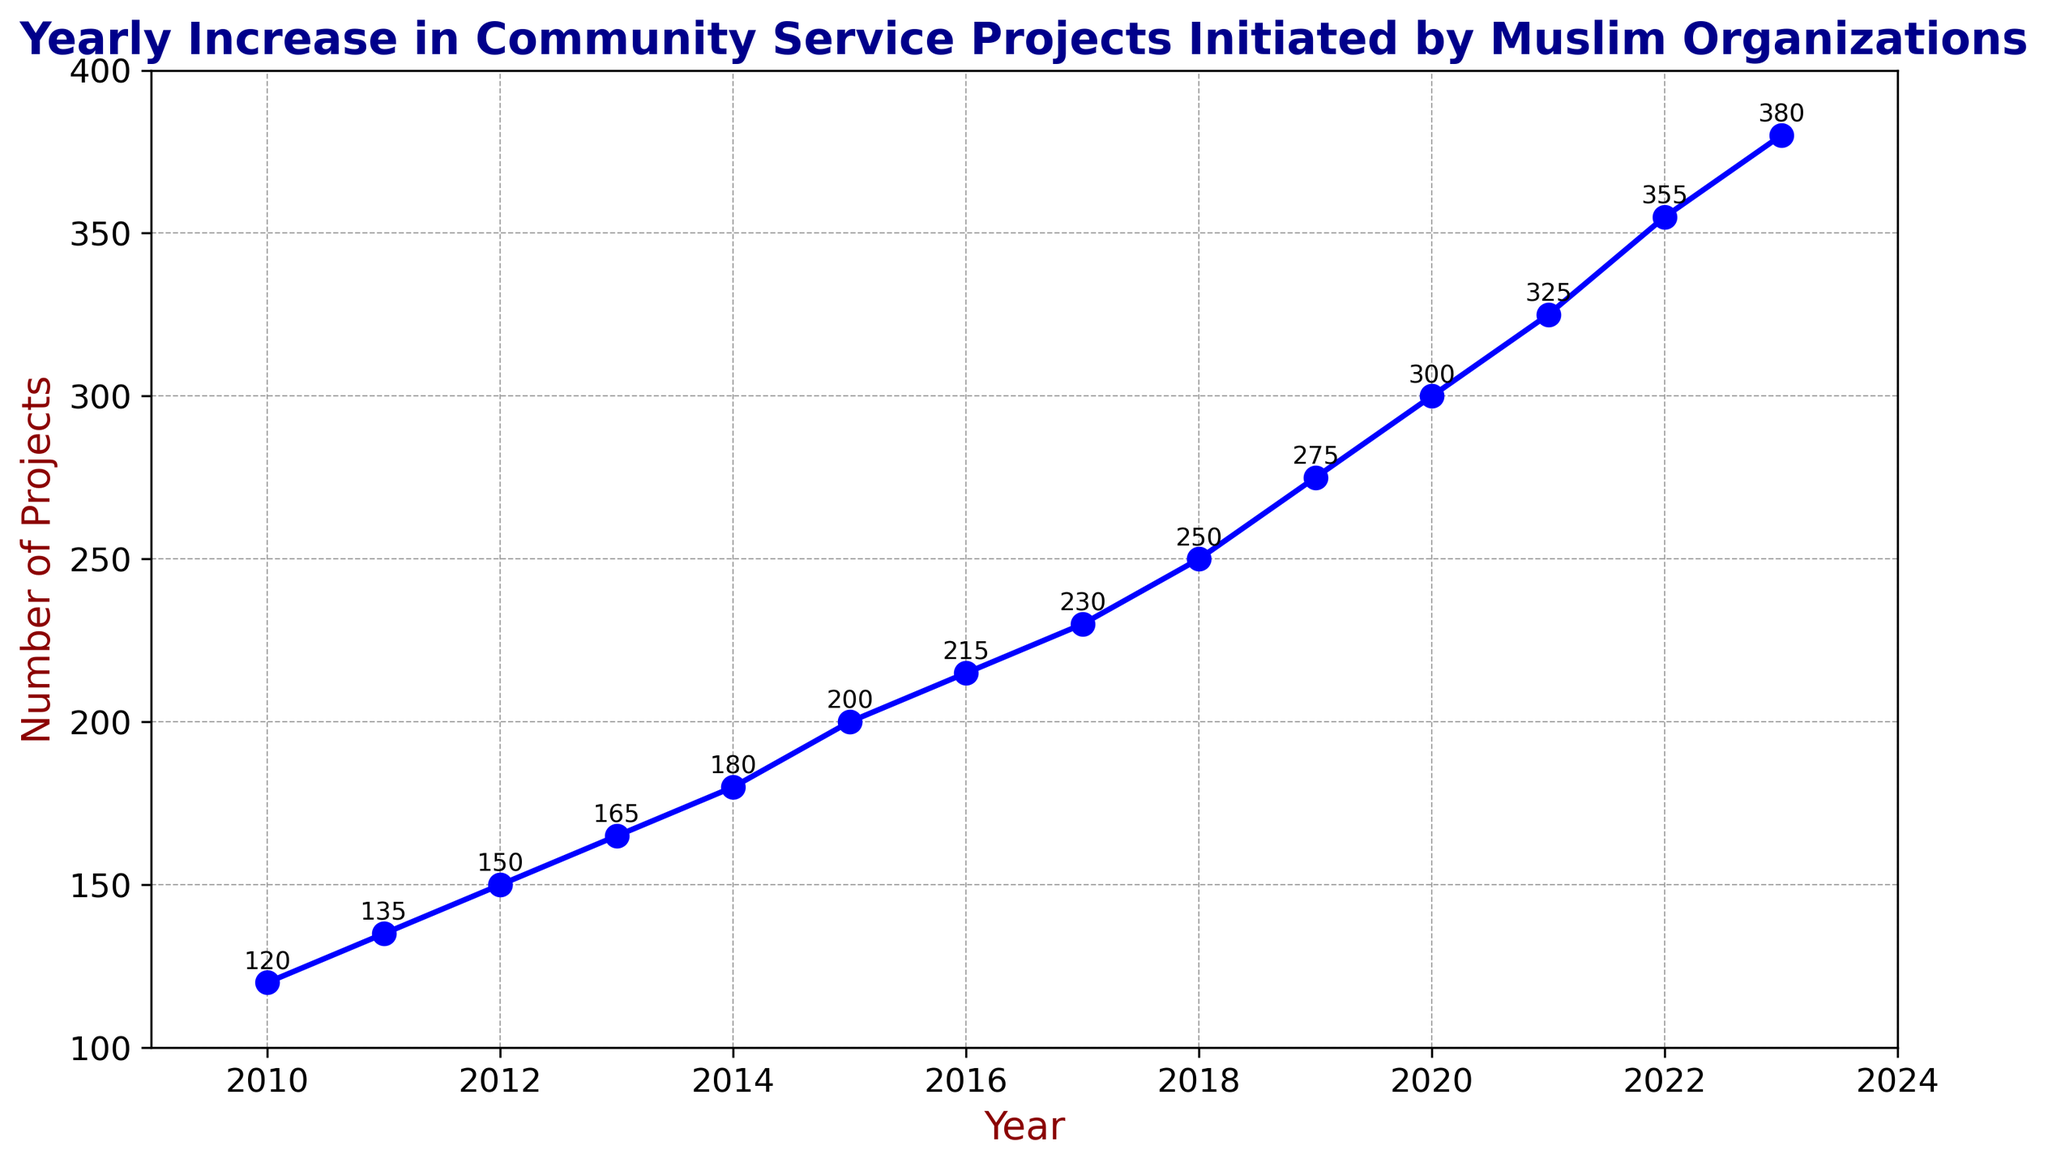What year saw the largest increase in the number of community service projects compared to the previous year? To identify the year with the largest increase, compare the number of projects year-over-year. The increase between 2021 and 2022 is 30 (355-325), which is the largest difference.
Answer: 2022 By how much did the number of projects increase from 2010 to 2020? Calculate the difference between the number of projects in 2020 and 2010, i.e., 300 - 120.
Answer: 180 How many community service projects were initiated in the median year of the data set? The median year of the dataset is 2016, as it is the middle value of the ordered years. The number of projects in 2016 was 215.
Answer: 215 In which years did the number of projects increase by exactly 25 compared to the previous year? Check the difference in projects year-to-year. The years 2018 (250-230), 2019 (275-250), and 2020 (300-275) each show an increase of 25 projects compared to the previous year.
Answer: 2018, 2019, 2020 Which year had the smallest number of community service projects? By how many projects? The chart shows that 2010 had the smallest number of projects, which is 120.
Answer: 2010, 120 projects Which two consecutive years had the same increase in the number of projects? Compare increases year-over-year. From 2010 to 2011 and 2011 to 2012, the increase was 15 projects each year (135-120 and 150-135).
Answer: 2010 to 2011 and 2011 to 2012 How does the number of projects in 2015 compare to that in 2023? The number in 2015 was 200 and in 2023 was 380. 380 - 200 = 180, so 2023 had 180 more projects than 2015.
Answer: 180 more projects in 2023 What is the average annual increase in the number of projects initiated from 2010 to 2023? First, calculate the total increase from 2010 to 2023: 380 - 120 = 260 projects. Then divide by the number of years: 260 / 13 = 20.
Answer: 20 projects per year What trend is observed in the number of projects over the years? The chart shows a consistent increase in the number of projects from 2010 to 2023, indicating sustained growth over the period.
Answer: Consistent increase 